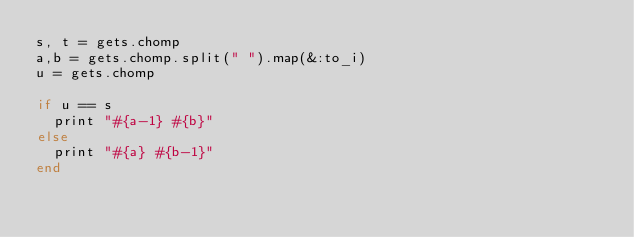<code> <loc_0><loc_0><loc_500><loc_500><_Ruby_>s, t = gets.chomp
a,b = gets.chomp.split(" ").map(&:to_i)
u = gets.chomp
 
if u == s 
  print "#{a-1} #{b}" 
else
  print "#{a} #{b-1}"
end</code> 